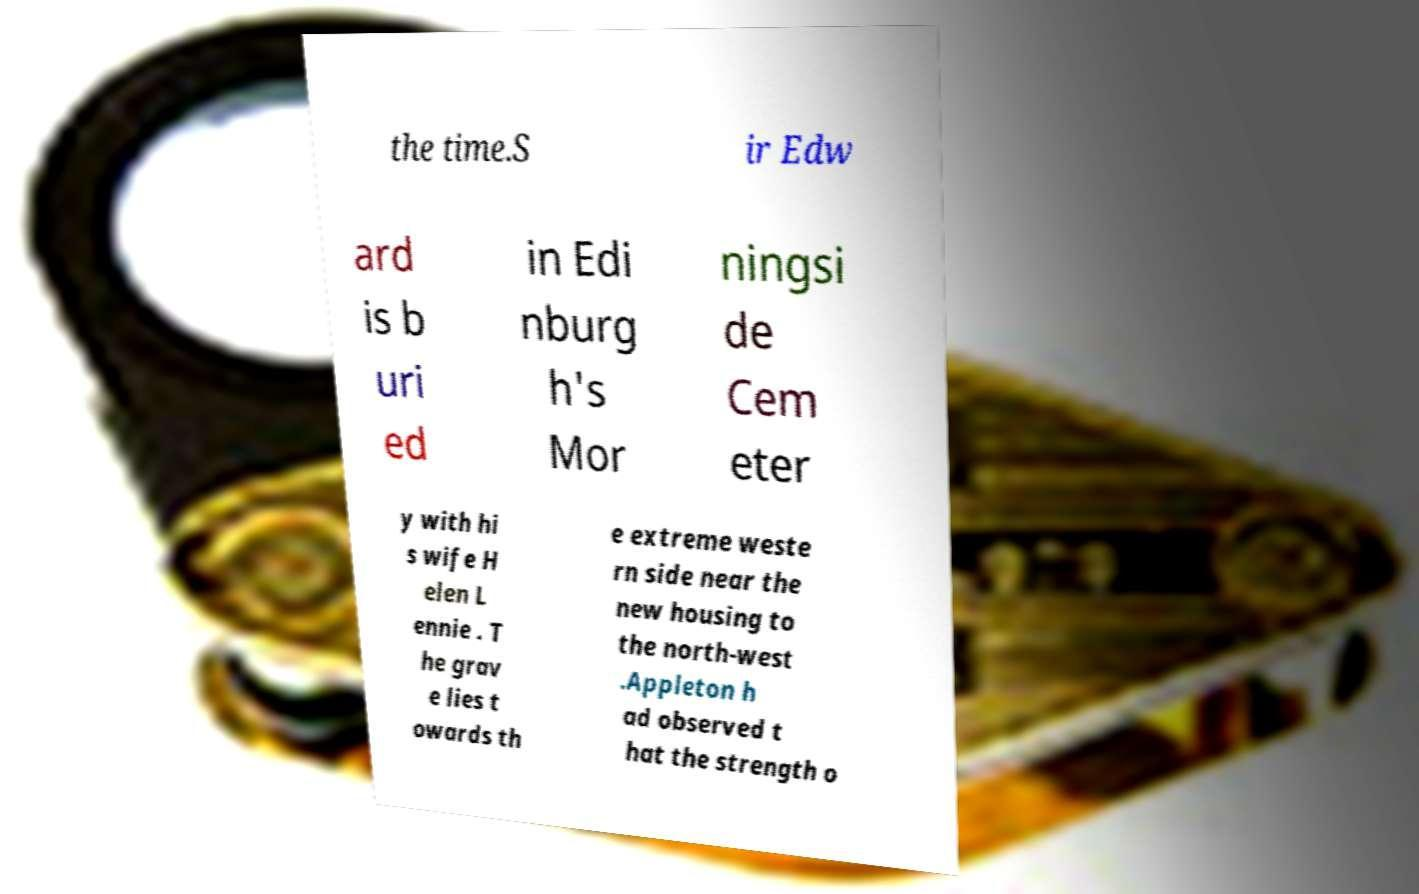Could you extract and type out the text from this image? the time.S ir Edw ard is b uri ed in Edi nburg h's Mor ningsi de Cem eter y with hi s wife H elen L ennie . T he grav e lies t owards th e extreme weste rn side near the new housing to the north-west .Appleton h ad observed t hat the strength o 